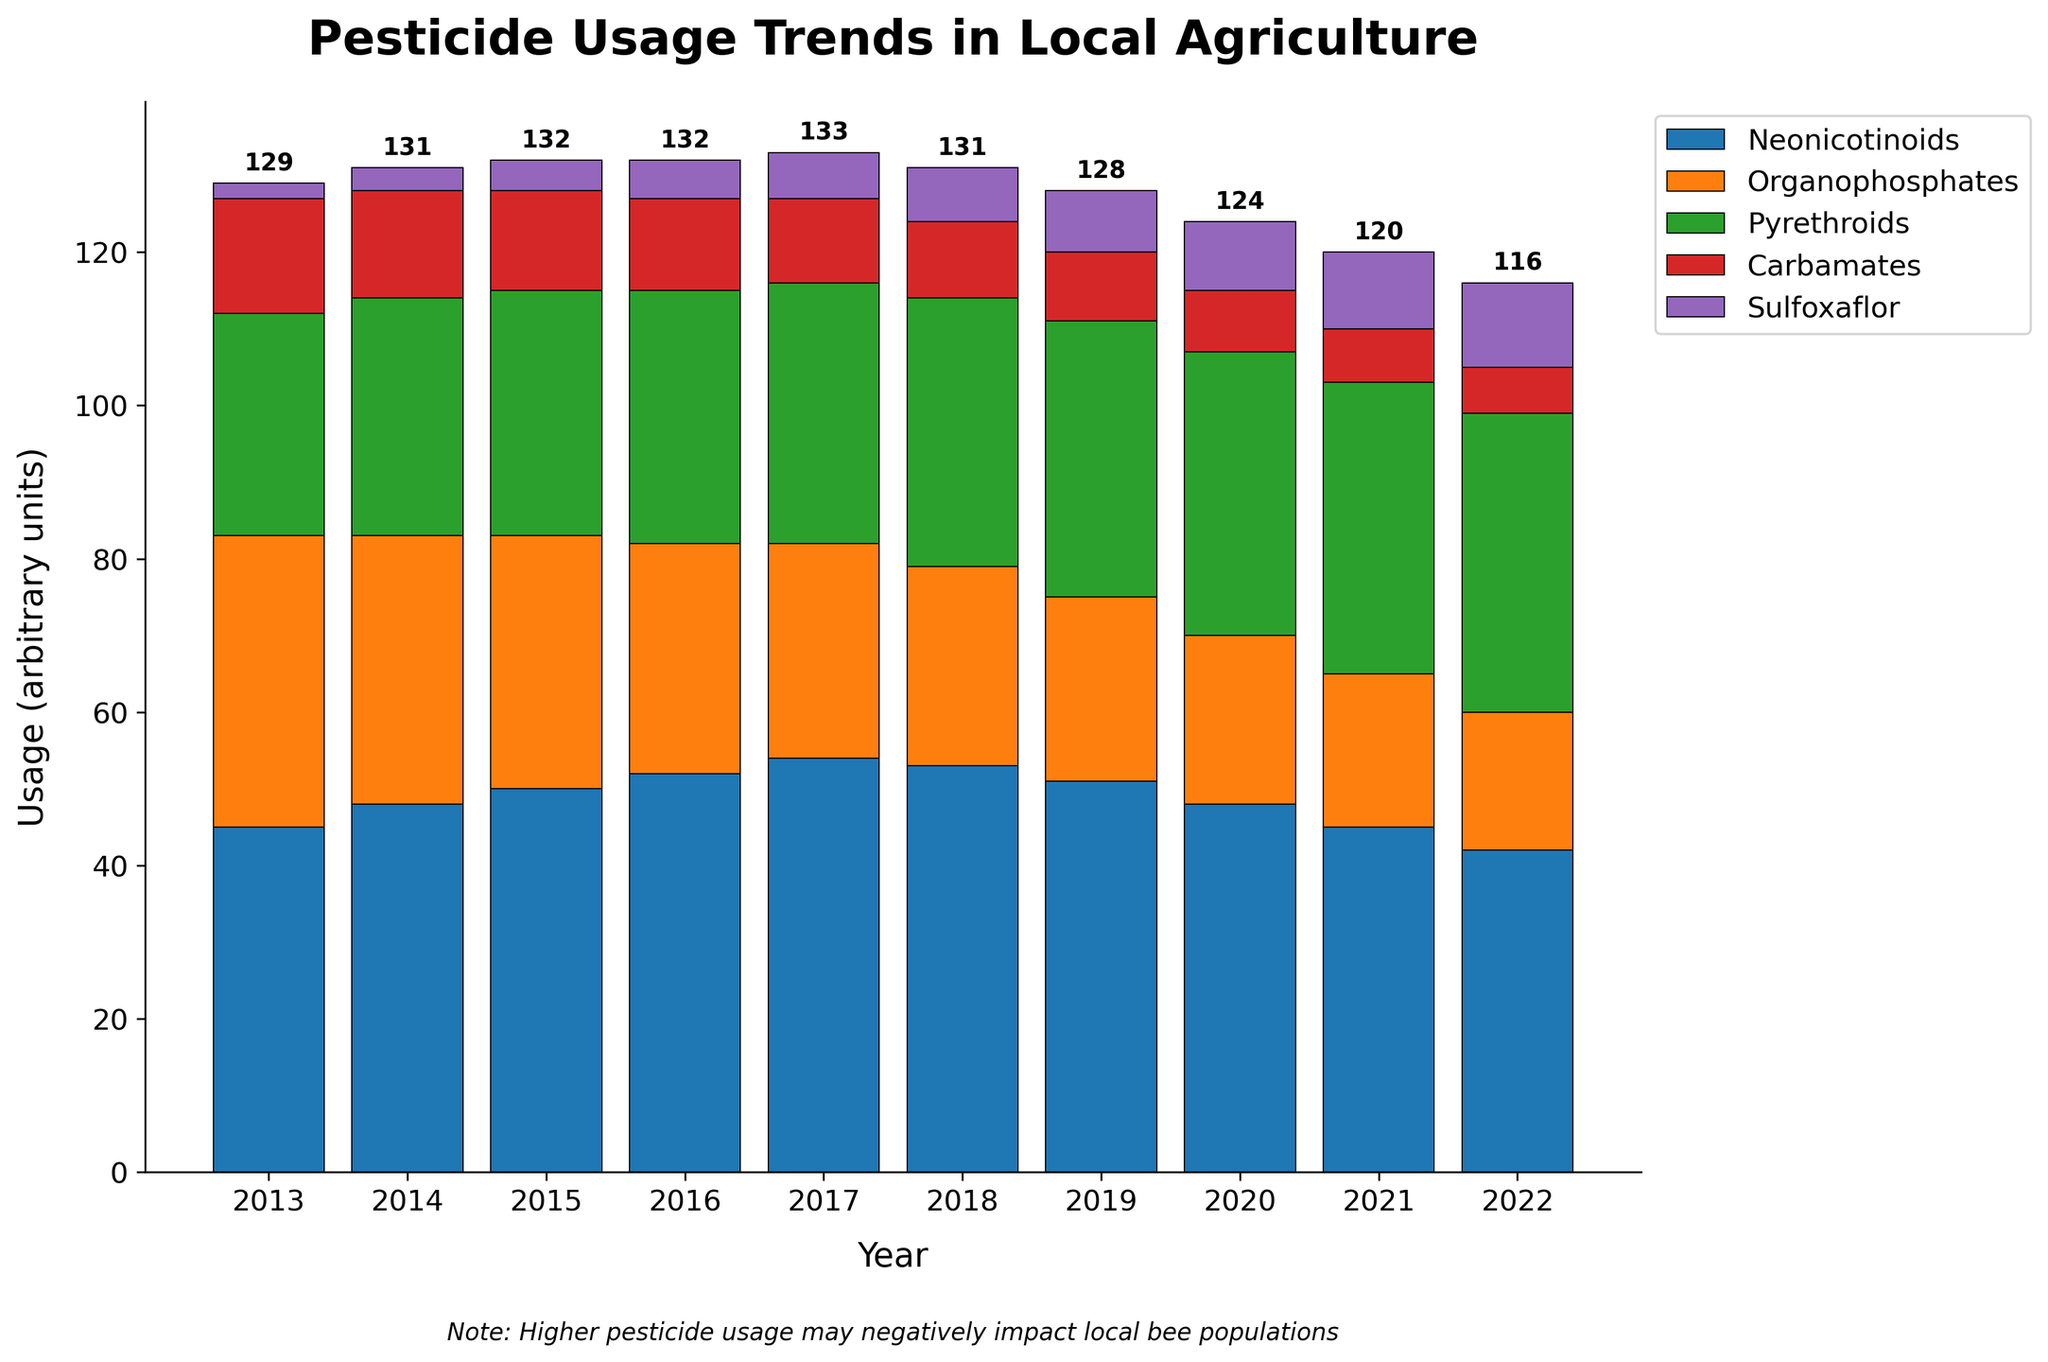Which pesticide had the highest usage in 2022? Observing the heights of the bars for the year 2022, Neonicotinoids had the highest bar.
Answer: Neonicotinoids By how much did the usage of Organophosphates decrease from 2013 to 2022? The usage of Organophosphates in 2013 was 38, and in 2022 it was 18. The difference between them is 38 - 18 = 20.
Answer: 20 Which year had the highest total pesticide usage? For each year, add up all values of the pesticides. The year 2017 has the highest sum: 54 + 28 + 34 + 11 + 6 = 133.
Answer: 2017 What is the average usage of Pyrethroids over the decade shown? Sum the values of Pyrethroids and divide by the number of years. The sum is 29 + 31 + 32 + 33 + 34 + 35 + 36 + 37 + 38 + 39 = 344, and the average is 344 / 10 = 34.4.
Answer: 34.4 Which pesticide showed a consistent increase in usage over the decade? Looking at the trends for each pesticide, Sulfoxaflor shows a consistent increase from 2 in 2013 to 11 in 2022.
Answer: Sulfoxaflor In which year did Neonicotinoids usage peak? By examining the series of Neonicotinoids, the highest value is at 2017 (54 units).
Answer: 2017 How did the total usage of Carbamates in 2022 compare to its usage in 2013? The usage in 2013 was 15 and in 2022 it was 6. Comparing them, 15 - 6 = 9 units decrease.
Answer: Decreased by 9 How does the usage of Sulfoxaflor in 2020 compare to its usage in 2013? Sulfoxaflor had a usage of 9 in 2020 and 2 in 2013. The difference is 9 - 2 = 7 units increase.
Answer: Increased by 7 What is the combined usage of Organophosphates and Carbamates in 2015? Sum the values for Organophosphates and Carbamates in 2015: 33 + 13 = 46.
Answer: 46 From the visual data, which year showed the least growth in total pesticide usage compared to its previous year? Calculate the year-over-year difference and observe the least increase or a decrease. The year 2018 had a slight decrease compared to 2017: 132 (2018) - 133 (2017) = -1.
Answer: 2018 